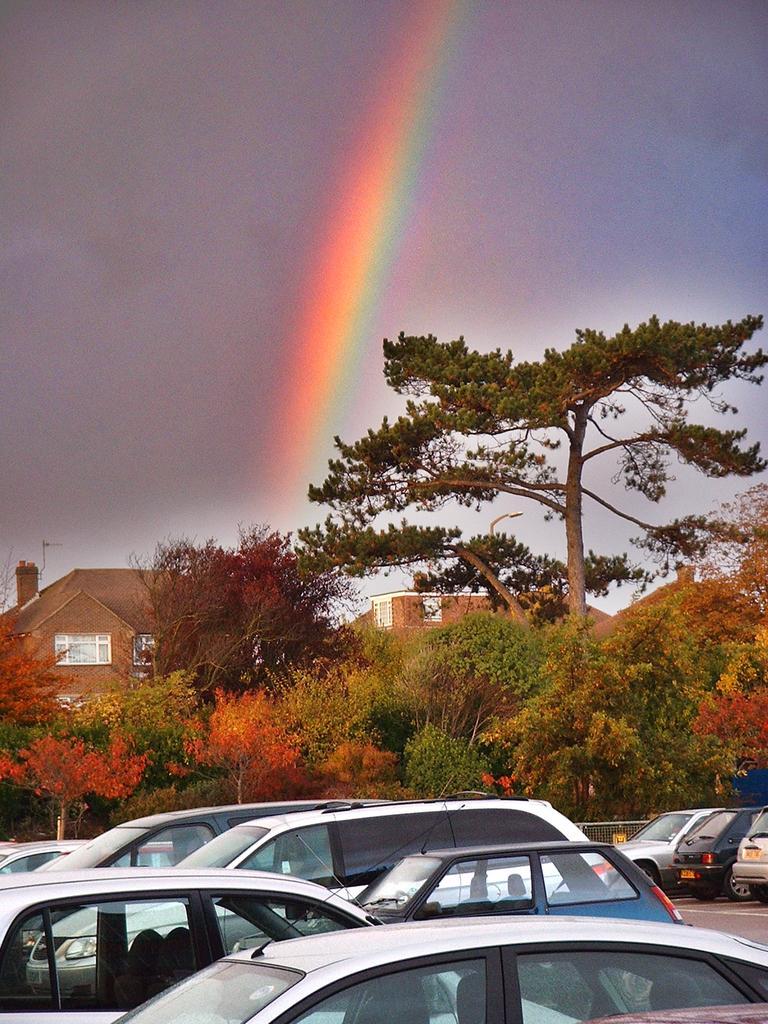Can you describe this image briefly? In the picture we can see some cars are parked and behind it, we can see some trees, buildings and the sky with a rainbow. 